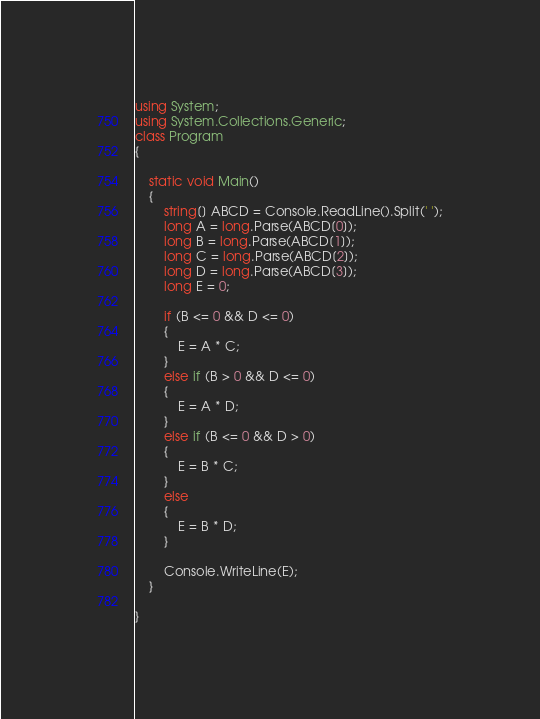Convert code to text. <code><loc_0><loc_0><loc_500><loc_500><_C#_>using System;
using System.Collections.Generic;
class Program
{

    static void Main()
    {
        string[] ABCD = Console.ReadLine().Split(' ');
        long A = long.Parse(ABCD[0]);
        long B = long.Parse(ABCD[1]);
        long C = long.Parse(ABCD[2]);
        long D = long.Parse(ABCD[3]);
        long E = 0;

        if (B <= 0 && D <= 0)
        {
            E = A * C;
        }
        else if (B > 0 && D <= 0)
        {
            E = A * D;
        }
        else if (B <= 0 && D > 0)
        {
            E = B * C;
        }
        else
        {
            E = B * D;
        }

        Console.WriteLine(E);
    }

}

</code> 